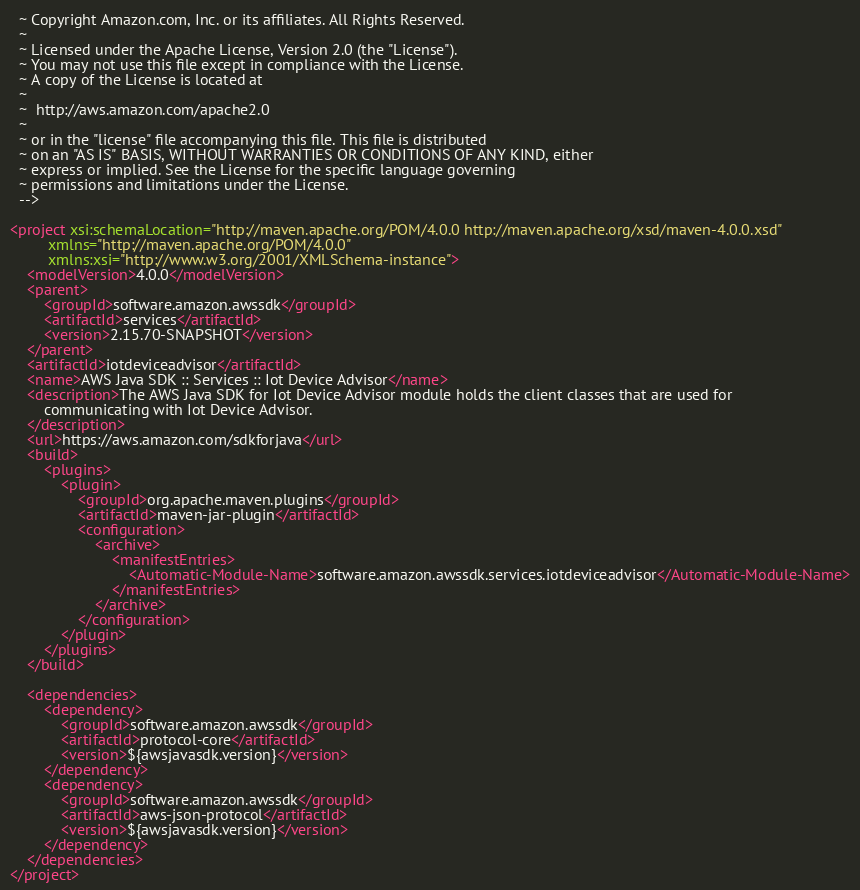<code> <loc_0><loc_0><loc_500><loc_500><_XML_>  ~ Copyright Amazon.com, Inc. or its affiliates. All Rights Reserved.
  ~
  ~ Licensed under the Apache License, Version 2.0 (the "License").
  ~ You may not use this file except in compliance with the License.
  ~ A copy of the License is located at
  ~
  ~  http://aws.amazon.com/apache2.0
  ~
  ~ or in the "license" file accompanying this file. This file is distributed
  ~ on an "AS IS" BASIS, WITHOUT WARRANTIES OR CONDITIONS OF ANY KIND, either
  ~ express or implied. See the License for the specific language governing
  ~ permissions and limitations under the License.
  -->

<project xsi:schemaLocation="http://maven.apache.org/POM/4.0.0 http://maven.apache.org/xsd/maven-4.0.0.xsd"
         xmlns="http://maven.apache.org/POM/4.0.0"
         xmlns:xsi="http://www.w3.org/2001/XMLSchema-instance">
    <modelVersion>4.0.0</modelVersion>
    <parent>
        <groupId>software.amazon.awssdk</groupId>
        <artifactId>services</artifactId>
        <version>2.15.70-SNAPSHOT</version>
    </parent>
    <artifactId>iotdeviceadvisor</artifactId>
    <name>AWS Java SDK :: Services :: Iot Device Advisor</name>
    <description>The AWS Java SDK for Iot Device Advisor module holds the client classes that are used for
        communicating with Iot Device Advisor.
    </description>
    <url>https://aws.amazon.com/sdkforjava</url>
    <build>
        <plugins>
            <plugin>
                <groupId>org.apache.maven.plugins</groupId>
                <artifactId>maven-jar-plugin</artifactId>
                <configuration>
                    <archive>
                        <manifestEntries>
                            <Automatic-Module-Name>software.amazon.awssdk.services.iotdeviceadvisor</Automatic-Module-Name>
                        </manifestEntries>
                    </archive>
                </configuration>
            </plugin>
        </plugins>
    </build>

    <dependencies>
        <dependency>
            <groupId>software.amazon.awssdk</groupId>
            <artifactId>protocol-core</artifactId>
            <version>${awsjavasdk.version}</version>
        </dependency>
        <dependency>
            <groupId>software.amazon.awssdk</groupId>
            <artifactId>aws-json-protocol</artifactId>
            <version>${awsjavasdk.version}</version>
        </dependency>
    </dependencies>
</project>
</code> 